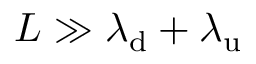Convert formula to latex. <formula><loc_0><loc_0><loc_500><loc_500>L \gg \lambda _ { d } + \lambda _ { u }</formula> 